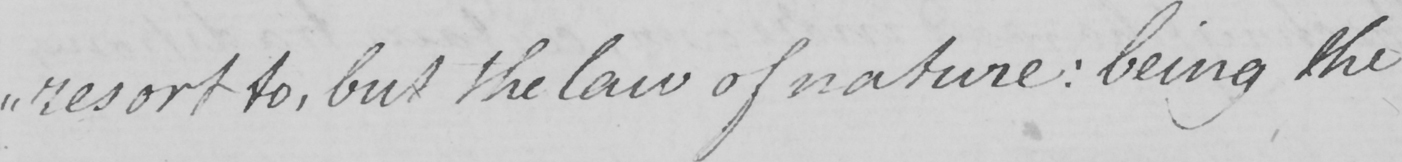Please transcribe the handwritten text in this image. " resort to , but the law of nature :  being the 